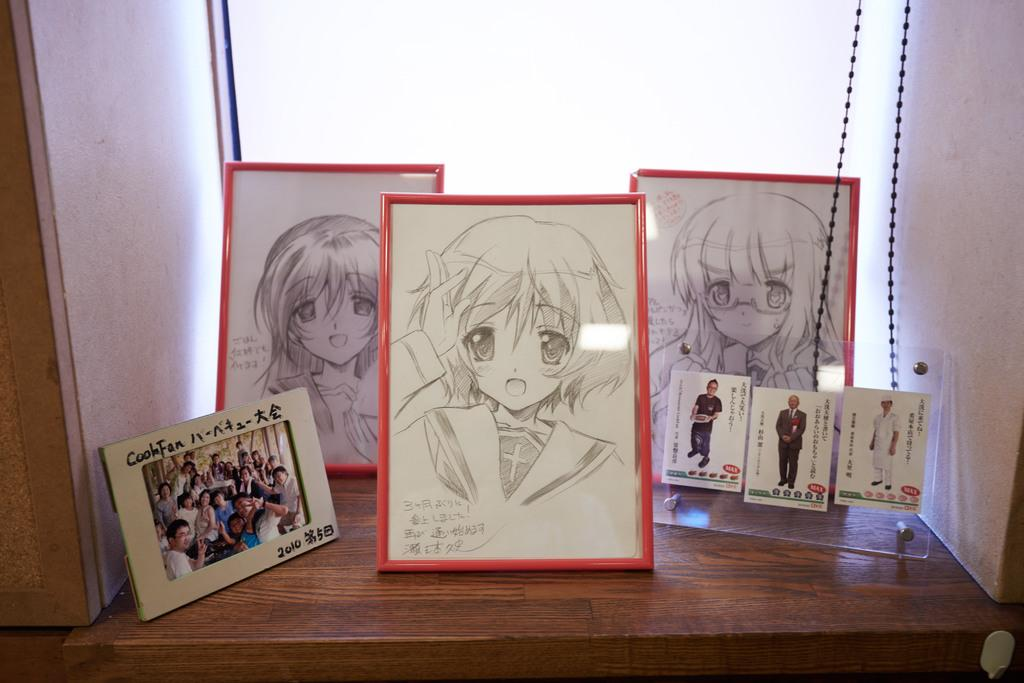What objects are placed on the wooden surface in the image? There are frames on a wooden surface in the image. What type of structure can be seen in the image? Walls are visible in the image. What color is the background of the image? The background of the image is white. Can you tell me how many hens are sitting on the wooden surface in the image? There are no hens present in the image; it features frames on a wooden surface. What type of ear is visible on the wall in the image? There is no ear visible on the wall in the image; only frames and walls are present. 